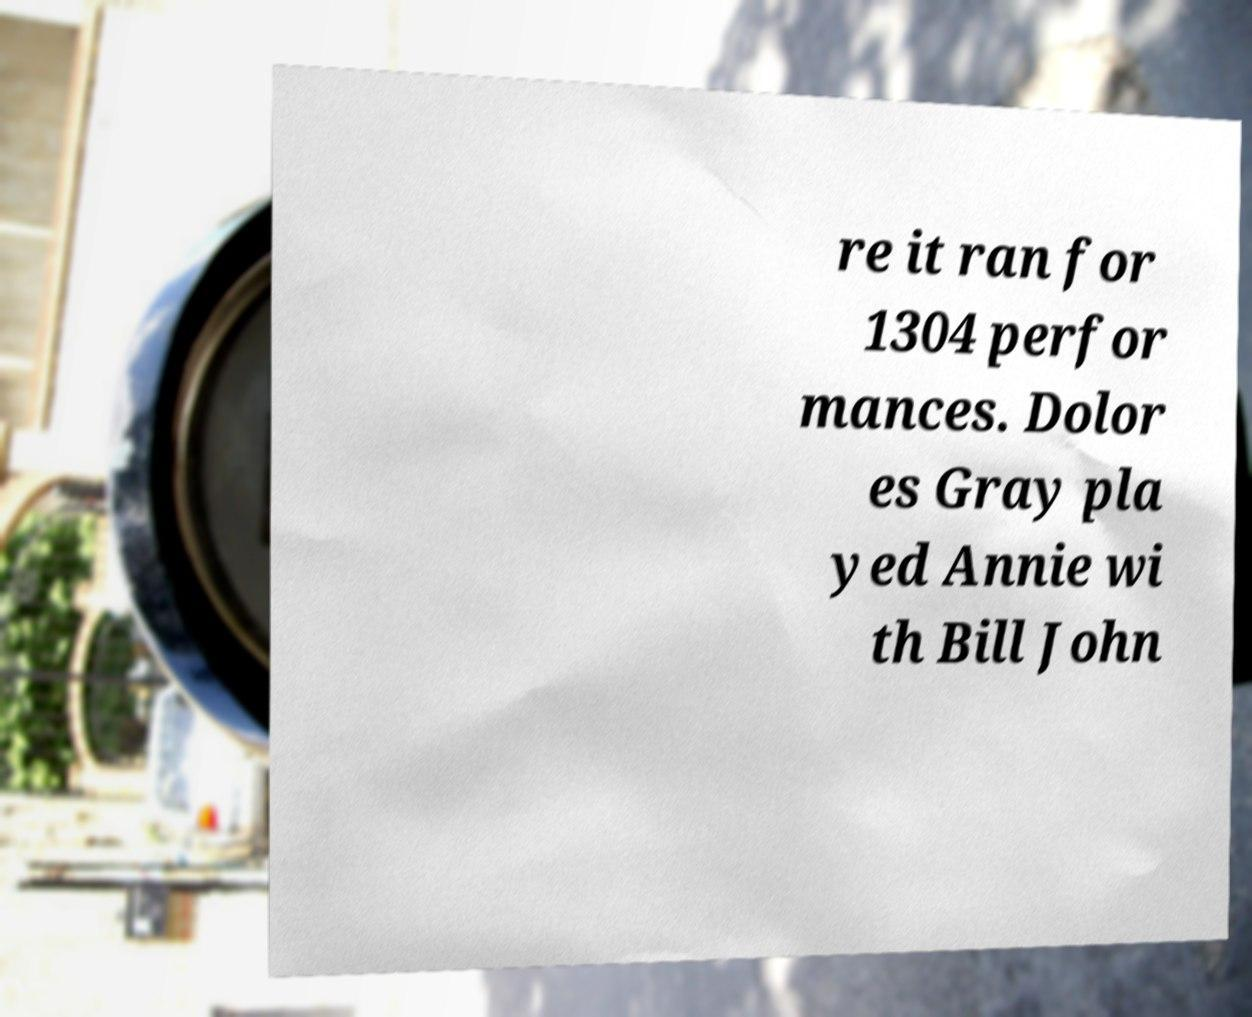What messages or text are displayed in this image? I need them in a readable, typed format. re it ran for 1304 perfor mances. Dolor es Gray pla yed Annie wi th Bill John 